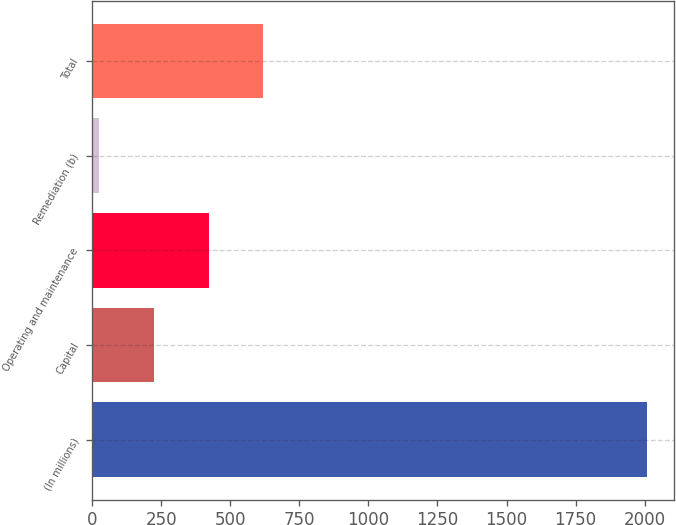Convert chart. <chart><loc_0><loc_0><loc_500><loc_500><bar_chart><fcel>(In millions)<fcel>Capital<fcel>Operating and maintenance<fcel>Remediation (b)<fcel>Total<nl><fcel>2007<fcel>223.2<fcel>421.4<fcel>25<fcel>619.6<nl></chart> 